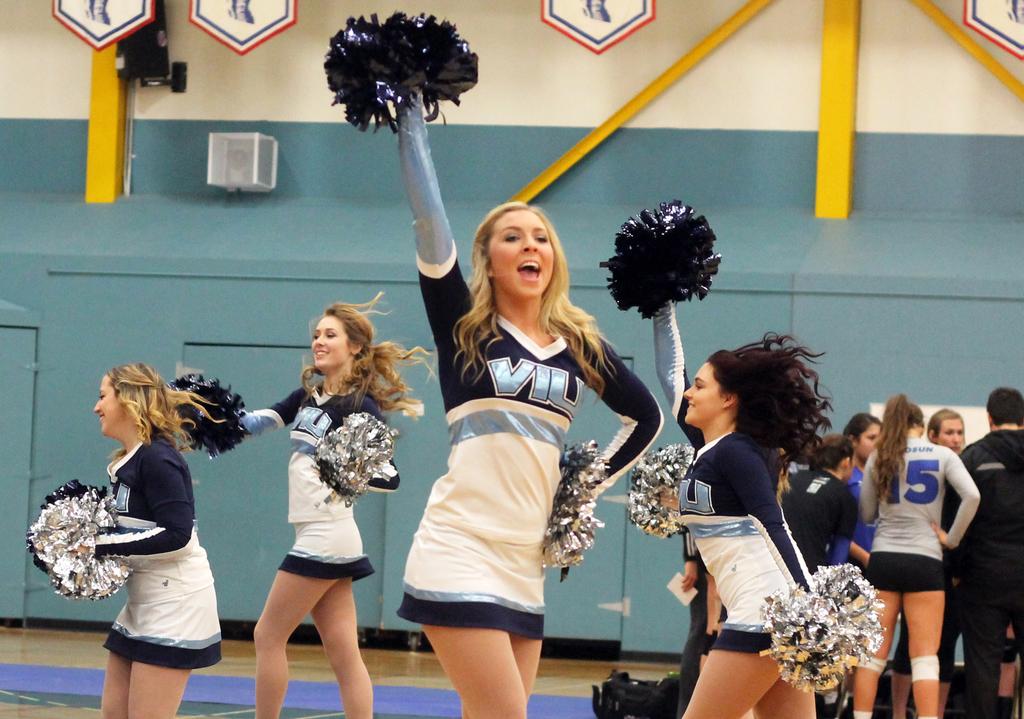What is the player's number in the background?
Ensure brevity in your answer.  15. 